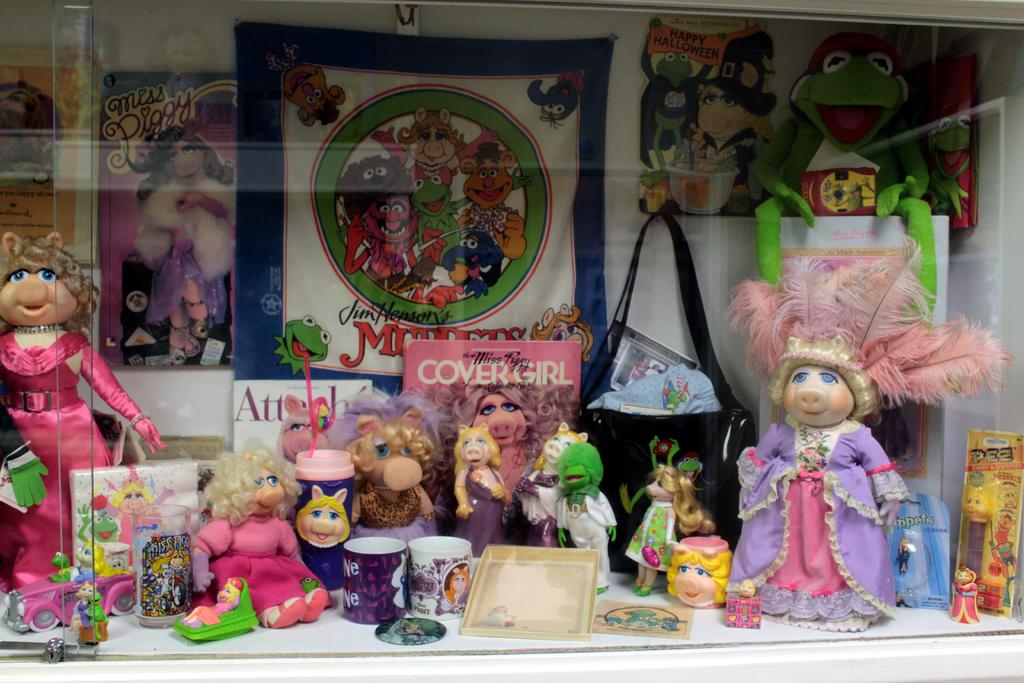<image>
Give a short and clear explanation of the subsequent image. A display of various Miss Piggy figures and items. 